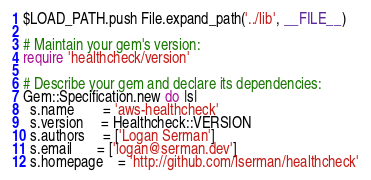<code> <loc_0><loc_0><loc_500><loc_500><_Ruby_>$LOAD_PATH.push File.expand_path('../lib', __FILE__)

# Maintain your gem's version:
require 'healthcheck/version'

# Describe your gem and declare its dependencies:
Gem::Specification.new do |s|
  s.name        = 'aws-healthcheck'
  s.version     = Healthcheck::VERSION
  s.authors     = ['Logan Serman']
  s.email       = ['logan@serman.dev']
  s.homepage    = 'http://github.com/lserman/healthcheck'</code> 